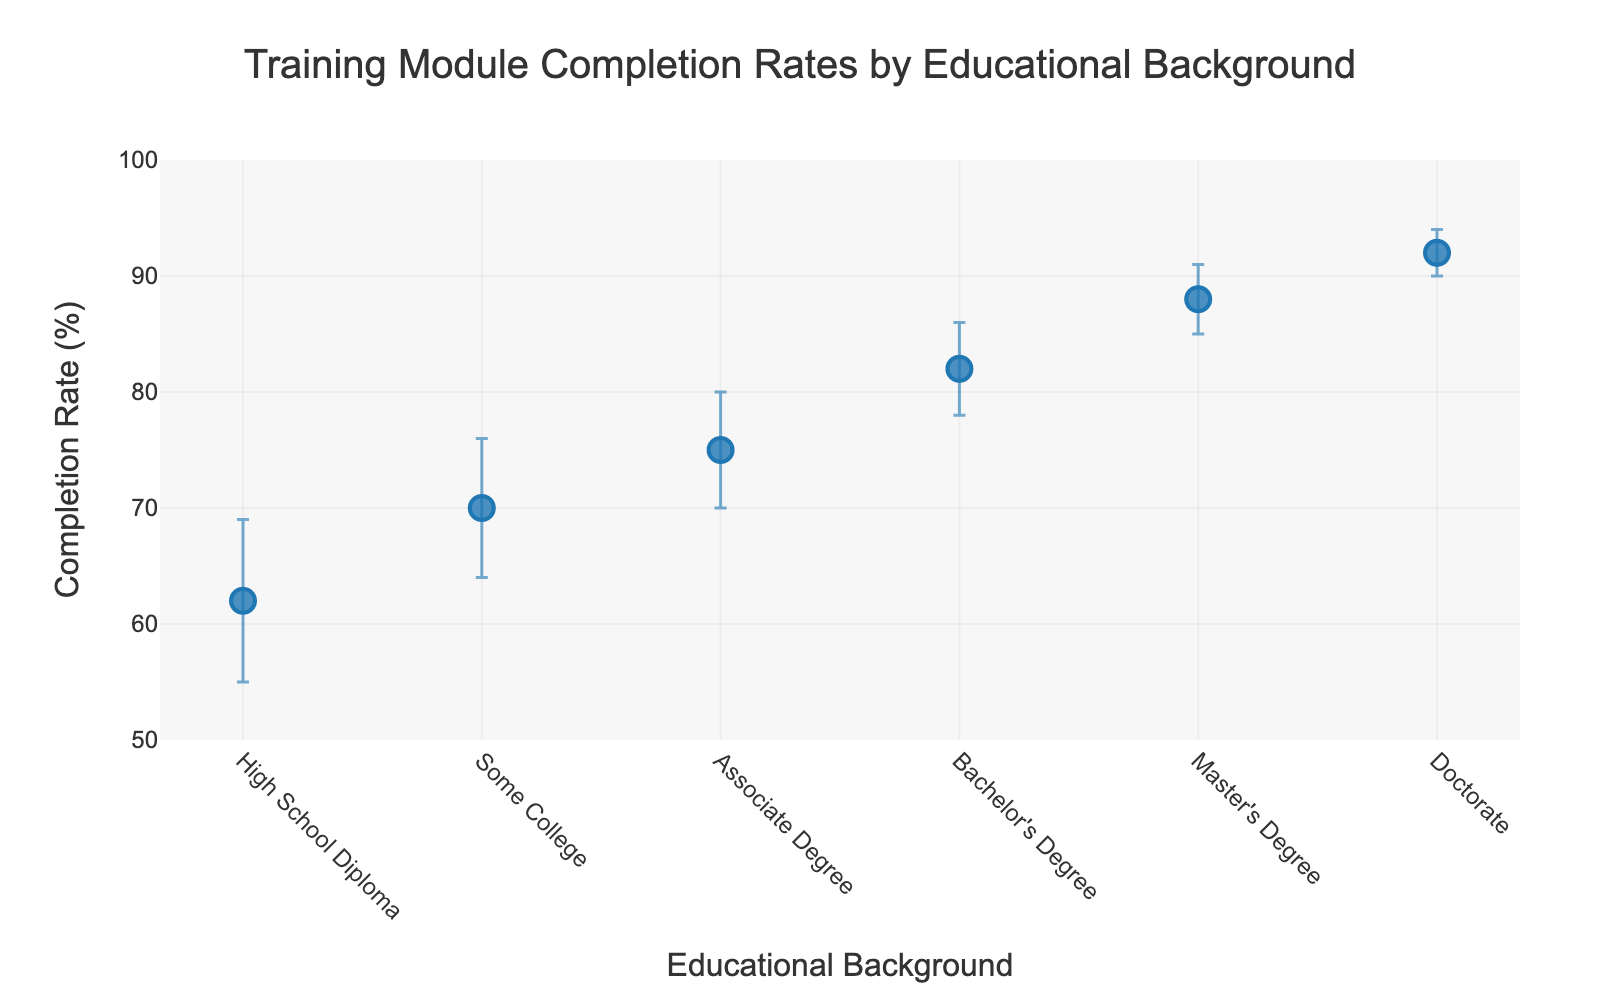What's the title of the plot? The title is located at the top of the figure. It provides a summary of what the plot represents. The title is "Training Module Completion Rates by Educational Background."
Answer: Training Module Completion Rates by Educational Background What is the completion rate for individuals with a Bachelor's Degree? Look for the data point labeled "Bachelor's Degree" on the x-axis and check the corresponding y-axis value. The completion rate for those with a Bachelor's Degree is 82%.
Answer: 82% Which educational background has the lowest completion rate? Compare the y-axis values for all educational backgrounds. The "High School Diploma" has the lowest completion rate at 62%.
Answer: High School Diploma How much is the error margin for the completion rate of individuals with an Associate Degree? Look for the data point labeled "Associate Degree" and check the error bar for that point. The error margin is 5%.
Answer: 5% What is the range of completion rates covered by the Doctorate's error bars? The completion rate for a Doctorate is 92% with an error of 2%. So, the range is from 92% - 2% to 92% + 2%, which is 90% to 94%.
Answer: 90% to 94% Which educational background has the highest completion rate, and what is that rate? Compare the y-axis values for all educational backgrounds. The "Doctorate" has the highest completion rate at 92%.
Answer: Doctorate, 92% What is the overall trend of completion rates as the educational background increases? Observe the progression of the dots from "High School Diploma" to "Doctorate." The completion rate increases as the educational background increases.
Answer: Increases Which educational backgrounds have completion rates within the range of 70% to 80%? Look for data points with values between 70% and 80% on the y-axis. "Some College" has a completion rate of 70%, and "Associate Degree" has a completion rate of 75%.
Answer: Some College, Associate Degree How much higher is the completion rate for a Master's Degree compared to a High School Diploma? Find the completion rates for "Master's Degree" and "High School Diploma" and subtract the lower from the higher: 88% - 62% = 26%.
Answer: 26% By how much does the error margin decrease as we go from a Bachelor's Degree to a Doctorate? The error margin for a Bachelor's Degree is 4%, and for a Doctorate, it is 2%. The decrease is 4% - 2% = 2%.
Answer: 2% 